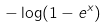Convert formula to latex. <formula><loc_0><loc_0><loc_500><loc_500>- \log ( 1 - e ^ { x } )</formula> 